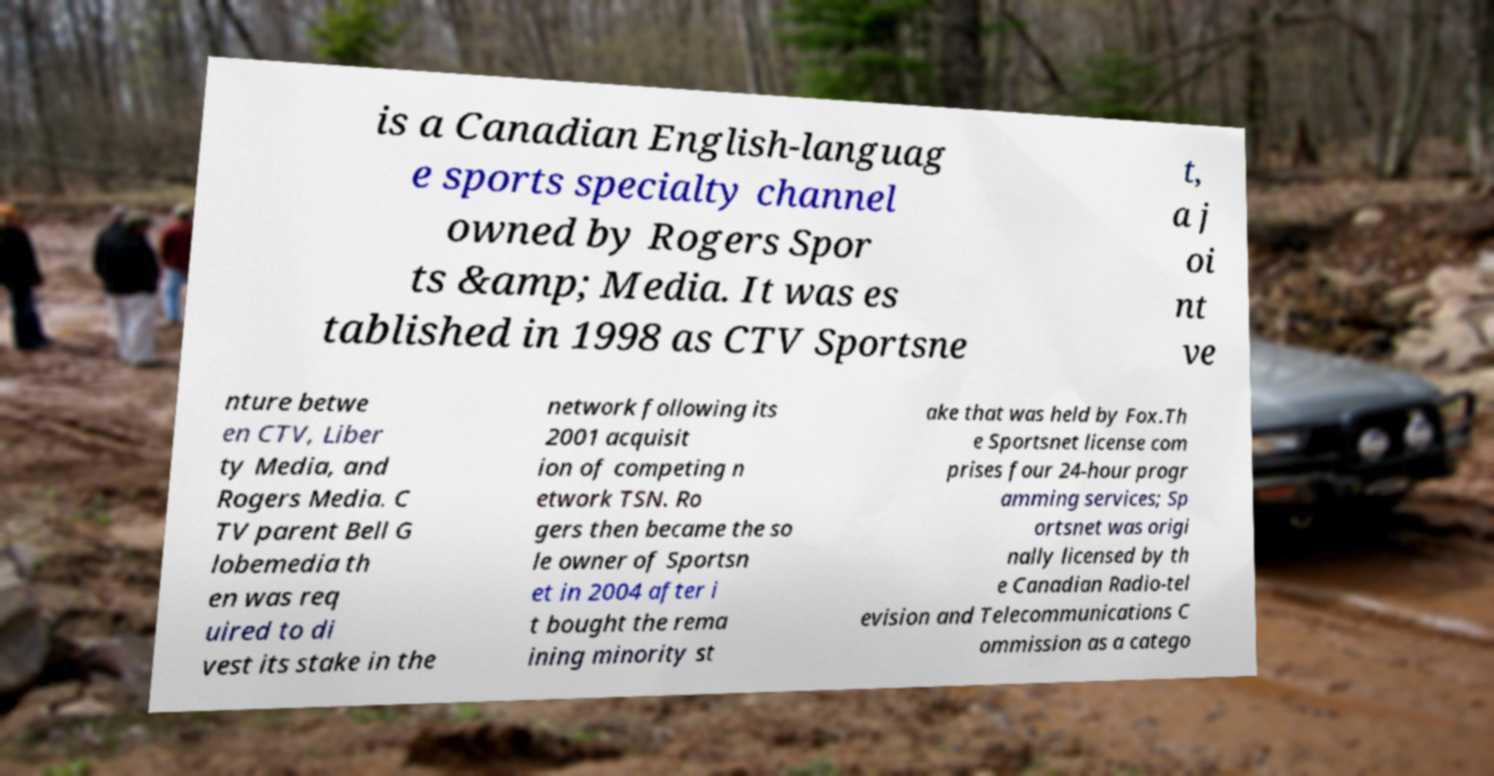What messages or text are displayed in this image? I need them in a readable, typed format. is a Canadian English-languag e sports specialty channel owned by Rogers Spor ts &amp; Media. It was es tablished in 1998 as CTV Sportsne t, a j oi nt ve nture betwe en CTV, Liber ty Media, and Rogers Media. C TV parent Bell G lobemedia th en was req uired to di vest its stake in the network following its 2001 acquisit ion of competing n etwork TSN. Ro gers then became the so le owner of Sportsn et in 2004 after i t bought the rema ining minority st ake that was held by Fox.Th e Sportsnet license com prises four 24-hour progr amming services; Sp ortsnet was origi nally licensed by th e Canadian Radio-tel evision and Telecommunications C ommission as a catego 